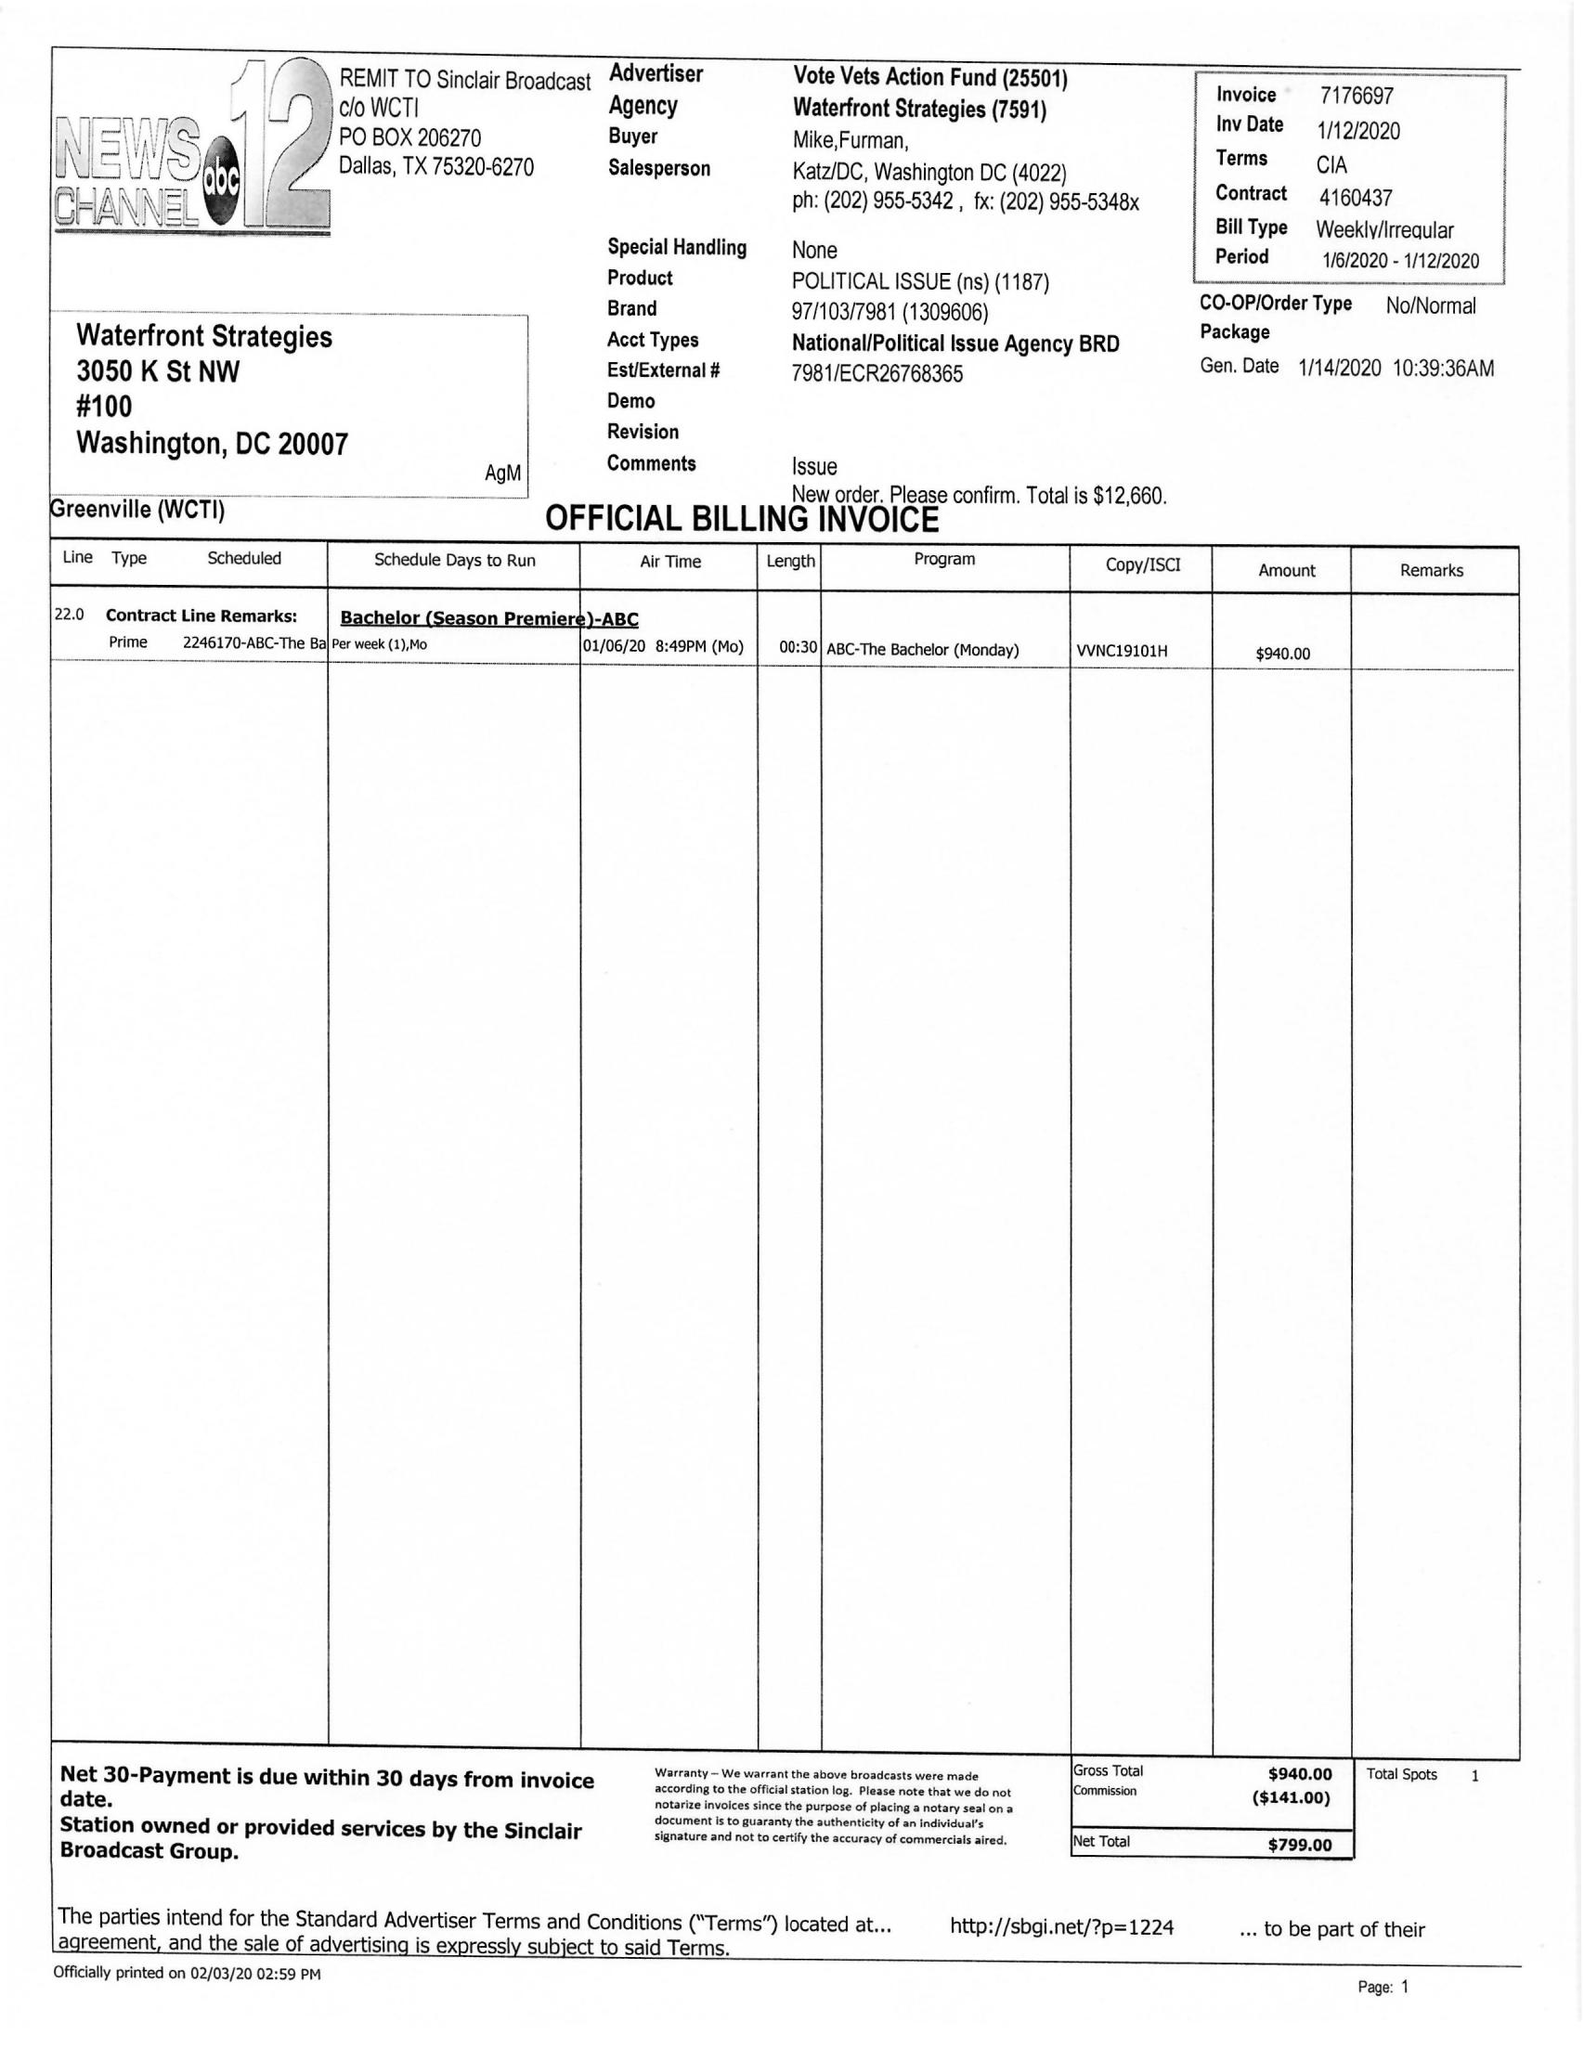What is the value for the advertiser?
Answer the question using a single word or phrase. VOTE VETS ACTION FUND 